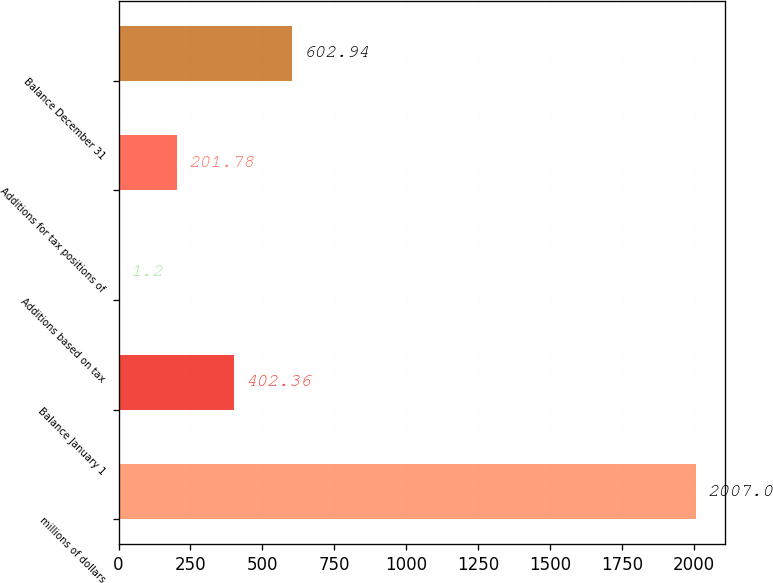Convert chart to OTSL. <chart><loc_0><loc_0><loc_500><loc_500><bar_chart><fcel>millions of dollars<fcel>Balance January 1<fcel>Additions based on tax<fcel>Additions for tax positions of<fcel>Balance December 31<nl><fcel>2007<fcel>402.36<fcel>1.2<fcel>201.78<fcel>602.94<nl></chart> 